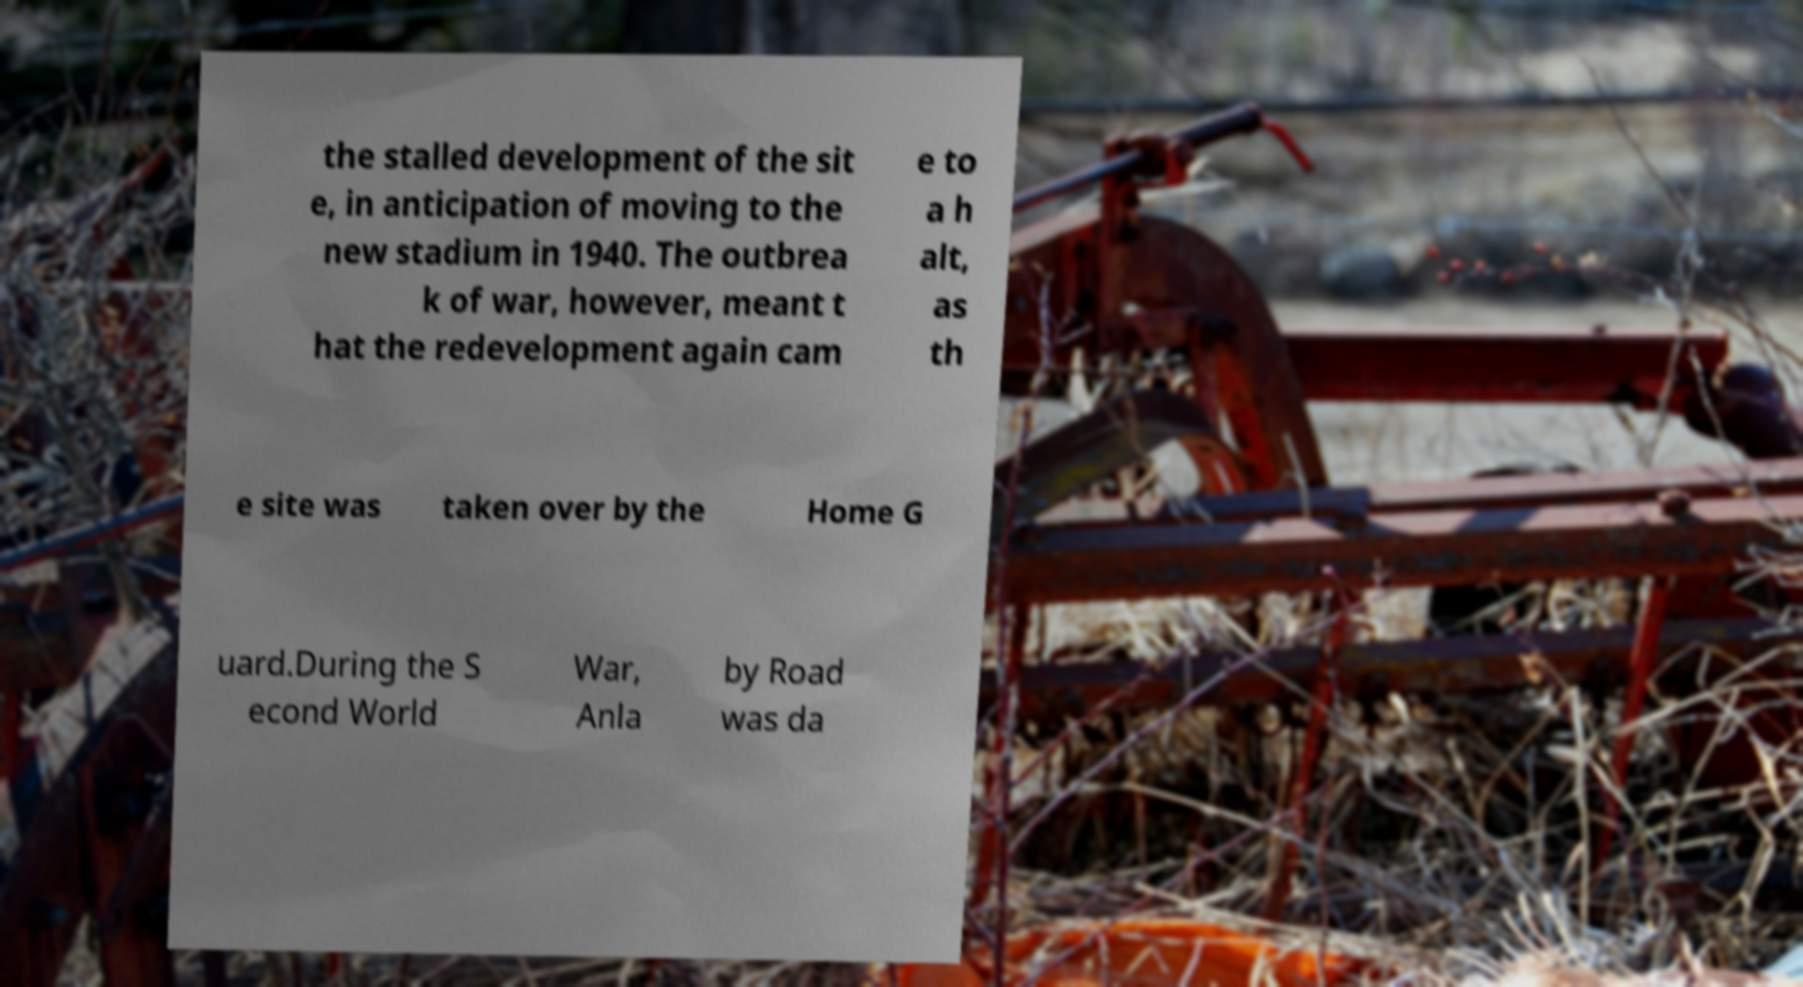I need the written content from this picture converted into text. Can you do that? the stalled development of the sit e, in anticipation of moving to the new stadium in 1940. The outbrea k of war, however, meant t hat the redevelopment again cam e to a h alt, as th e site was taken over by the Home G uard.During the S econd World War, Anla by Road was da 